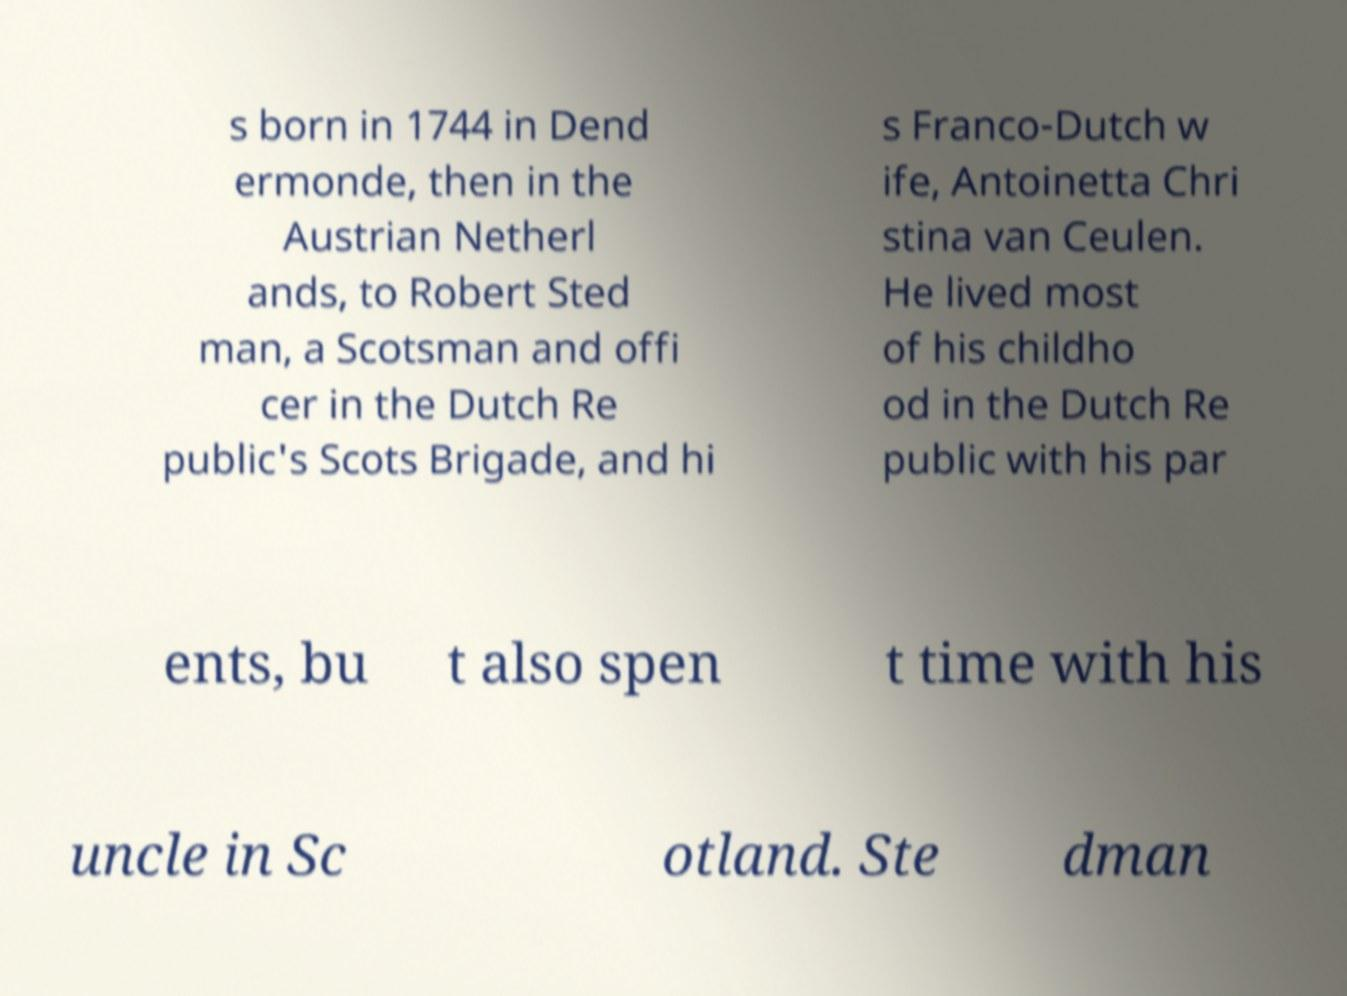Please identify and transcribe the text found in this image. s born in 1744 in Dend ermonde, then in the Austrian Netherl ands, to Robert Sted man, a Scotsman and offi cer in the Dutch Re public's Scots Brigade, and hi s Franco-Dutch w ife, Antoinetta Chri stina van Ceulen. He lived most of his childho od in the Dutch Re public with his par ents, bu t also spen t time with his uncle in Sc otland. Ste dman 